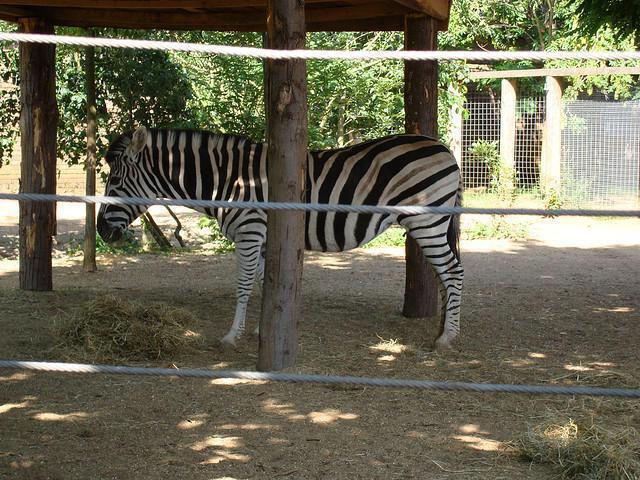How many zebras can be seen?
Give a very brief answer. 1. 